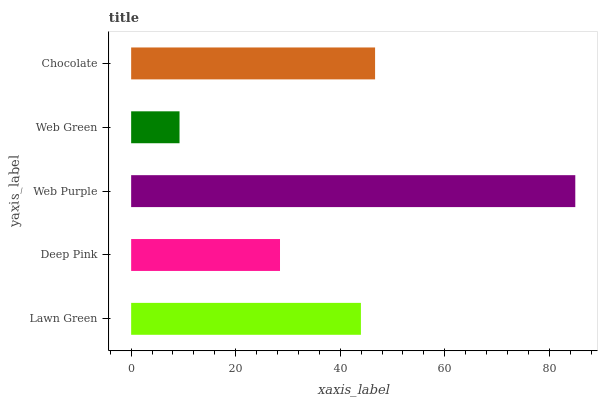Is Web Green the minimum?
Answer yes or no. Yes. Is Web Purple the maximum?
Answer yes or no. Yes. Is Deep Pink the minimum?
Answer yes or no. No. Is Deep Pink the maximum?
Answer yes or no. No. Is Lawn Green greater than Deep Pink?
Answer yes or no. Yes. Is Deep Pink less than Lawn Green?
Answer yes or no. Yes. Is Deep Pink greater than Lawn Green?
Answer yes or no. No. Is Lawn Green less than Deep Pink?
Answer yes or no. No. Is Lawn Green the high median?
Answer yes or no. Yes. Is Lawn Green the low median?
Answer yes or no. Yes. Is Chocolate the high median?
Answer yes or no. No. Is Web Green the low median?
Answer yes or no. No. 